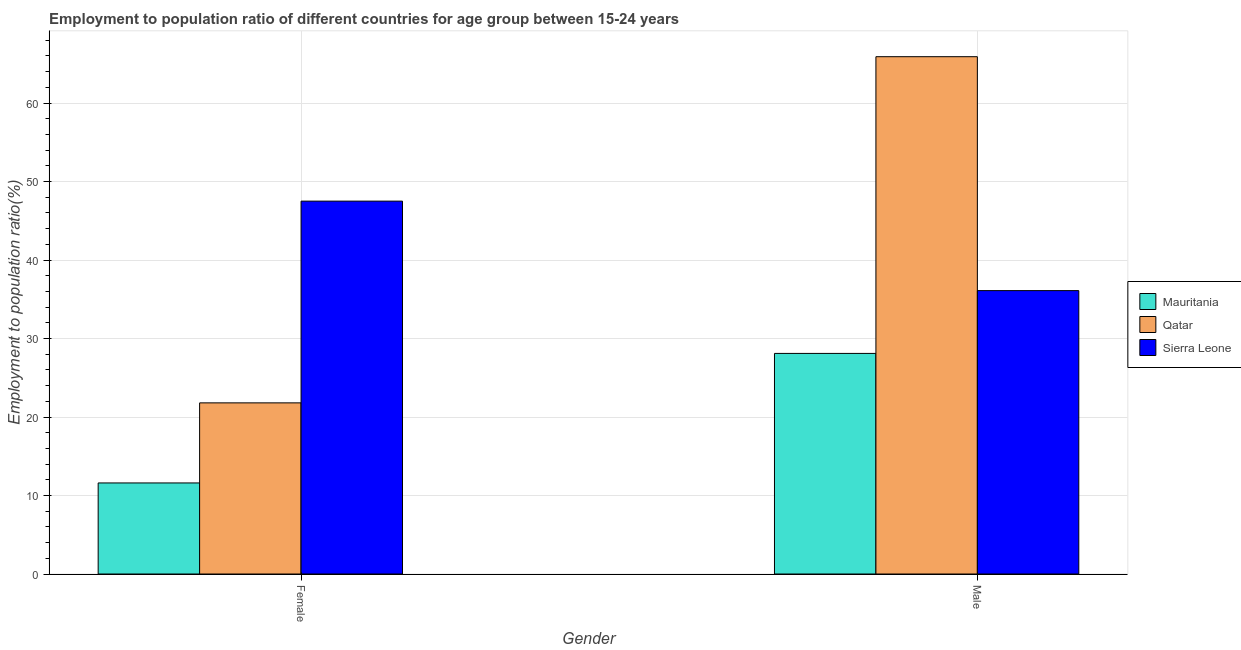Are the number of bars per tick equal to the number of legend labels?
Provide a succinct answer. Yes. What is the label of the 1st group of bars from the left?
Offer a terse response. Female. What is the employment to population ratio(male) in Mauritania?
Give a very brief answer. 28.1. Across all countries, what is the maximum employment to population ratio(male)?
Your answer should be compact. 65.9. Across all countries, what is the minimum employment to population ratio(female)?
Your answer should be compact. 11.6. In which country was the employment to population ratio(male) maximum?
Provide a short and direct response. Qatar. In which country was the employment to population ratio(male) minimum?
Give a very brief answer. Mauritania. What is the total employment to population ratio(male) in the graph?
Your response must be concise. 130.1. What is the difference between the employment to population ratio(female) in Qatar and that in Mauritania?
Provide a succinct answer. 10.2. What is the difference between the employment to population ratio(female) in Mauritania and the employment to population ratio(male) in Sierra Leone?
Give a very brief answer. -24.5. What is the average employment to population ratio(male) per country?
Provide a succinct answer. 43.37. What is the difference between the employment to population ratio(male) and employment to population ratio(female) in Qatar?
Provide a succinct answer. 44.1. In how many countries, is the employment to population ratio(female) greater than 48 %?
Give a very brief answer. 0. What is the ratio of the employment to population ratio(female) in Sierra Leone to that in Qatar?
Make the answer very short. 2.18. Is the employment to population ratio(female) in Mauritania less than that in Sierra Leone?
Provide a short and direct response. Yes. In how many countries, is the employment to population ratio(male) greater than the average employment to population ratio(male) taken over all countries?
Provide a short and direct response. 1. What does the 1st bar from the left in Male represents?
Make the answer very short. Mauritania. What does the 1st bar from the right in Female represents?
Provide a short and direct response. Sierra Leone. How many bars are there?
Your answer should be very brief. 6. Are all the bars in the graph horizontal?
Give a very brief answer. No. What is the difference between two consecutive major ticks on the Y-axis?
Ensure brevity in your answer.  10. Are the values on the major ticks of Y-axis written in scientific E-notation?
Make the answer very short. No. Does the graph contain grids?
Your answer should be very brief. Yes. Where does the legend appear in the graph?
Make the answer very short. Center right. How are the legend labels stacked?
Offer a terse response. Vertical. What is the title of the graph?
Your answer should be compact. Employment to population ratio of different countries for age group between 15-24 years. Does "Lebanon" appear as one of the legend labels in the graph?
Your answer should be very brief. No. What is the label or title of the Y-axis?
Your response must be concise. Employment to population ratio(%). What is the Employment to population ratio(%) in Mauritania in Female?
Your answer should be very brief. 11.6. What is the Employment to population ratio(%) in Qatar in Female?
Provide a short and direct response. 21.8. What is the Employment to population ratio(%) in Sierra Leone in Female?
Provide a succinct answer. 47.5. What is the Employment to population ratio(%) of Mauritania in Male?
Give a very brief answer. 28.1. What is the Employment to population ratio(%) of Qatar in Male?
Provide a succinct answer. 65.9. What is the Employment to population ratio(%) in Sierra Leone in Male?
Provide a short and direct response. 36.1. Across all Gender, what is the maximum Employment to population ratio(%) in Mauritania?
Provide a short and direct response. 28.1. Across all Gender, what is the maximum Employment to population ratio(%) in Qatar?
Keep it short and to the point. 65.9. Across all Gender, what is the maximum Employment to population ratio(%) of Sierra Leone?
Offer a very short reply. 47.5. Across all Gender, what is the minimum Employment to population ratio(%) of Mauritania?
Your response must be concise. 11.6. Across all Gender, what is the minimum Employment to population ratio(%) of Qatar?
Your answer should be very brief. 21.8. Across all Gender, what is the minimum Employment to population ratio(%) in Sierra Leone?
Give a very brief answer. 36.1. What is the total Employment to population ratio(%) in Mauritania in the graph?
Offer a terse response. 39.7. What is the total Employment to population ratio(%) in Qatar in the graph?
Your response must be concise. 87.7. What is the total Employment to population ratio(%) in Sierra Leone in the graph?
Give a very brief answer. 83.6. What is the difference between the Employment to population ratio(%) in Mauritania in Female and that in Male?
Your answer should be very brief. -16.5. What is the difference between the Employment to population ratio(%) of Qatar in Female and that in Male?
Your answer should be very brief. -44.1. What is the difference between the Employment to population ratio(%) in Sierra Leone in Female and that in Male?
Provide a succinct answer. 11.4. What is the difference between the Employment to population ratio(%) in Mauritania in Female and the Employment to population ratio(%) in Qatar in Male?
Ensure brevity in your answer.  -54.3. What is the difference between the Employment to population ratio(%) of Mauritania in Female and the Employment to population ratio(%) of Sierra Leone in Male?
Provide a succinct answer. -24.5. What is the difference between the Employment to population ratio(%) in Qatar in Female and the Employment to population ratio(%) in Sierra Leone in Male?
Give a very brief answer. -14.3. What is the average Employment to population ratio(%) in Mauritania per Gender?
Your answer should be compact. 19.85. What is the average Employment to population ratio(%) of Qatar per Gender?
Give a very brief answer. 43.85. What is the average Employment to population ratio(%) of Sierra Leone per Gender?
Give a very brief answer. 41.8. What is the difference between the Employment to population ratio(%) of Mauritania and Employment to population ratio(%) of Sierra Leone in Female?
Provide a short and direct response. -35.9. What is the difference between the Employment to population ratio(%) in Qatar and Employment to population ratio(%) in Sierra Leone in Female?
Your response must be concise. -25.7. What is the difference between the Employment to population ratio(%) in Mauritania and Employment to population ratio(%) in Qatar in Male?
Your answer should be compact. -37.8. What is the difference between the Employment to population ratio(%) in Mauritania and Employment to population ratio(%) in Sierra Leone in Male?
Offer a very short reply. -8. What is the difference between the Employment to population ratio(%) of Qatar and Employment to population ratio(%) of Sierra Leone in Male?
Ensure brevity in your answer.  29.8. What is the ratio of the Employment to population ratio(%) in Mauritania in Female to that in Male?
Provide a short and direct response. 0.41. What is the ratio of the Employment to population ratio(%) of Qatar in Female to that in Male?
Your response must be concise. 0.33. What is the ratio of the Employment to population ratio(%) of Sierra Leone in Female to that in Male?
Offer a terse response. 1.32. What is the difference between the highest and the second highest Employment to population ratio(%) of Qatar?
Provide a short and direct response. 44.1. What is the difference between the highest and the lowest Employment to population ratio(%) of Mauritania?
Ensure brevity in your answer.  16.5. What is the difference between the highest and the lowest Employment to population ratio(%) in Qatar?
Provide a succinct answer. 44.1. 